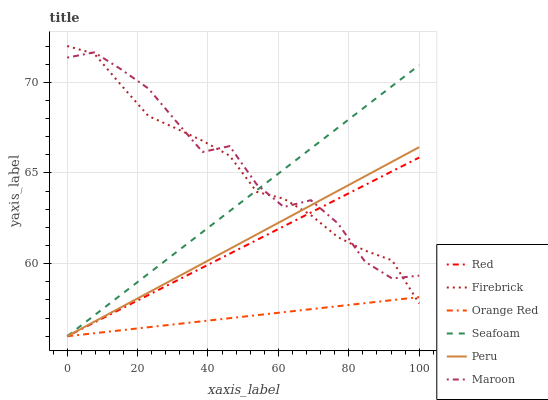Does Orange Red have the minimum area under the curve?
Answer yes or no. Yes. Does Maroon have the maximum area under the curve?
Answer yes or no. Yes. Does Seafoam have the minimum area under the curve?
Answer yes or no. No. Does Seafoam have the maximum area under the curve?
Answer yes or no. No. Is Orange Red the smoothest?
Answer yes or no. Yes. Is Maroon the roughest?
Answer yes or no. Yes. Is Seafoam the smoothest?
Answer yes or no. No. Is Seafoam the roughest?
Answer yes or no. No. Does Seafoam have the lowest value?
Answer yes or no. Yes. Does Maroon have the lowest value?
Answer yes or no. No. Does Firebrick have the highest value?
Answer yes or no. Yes. Does Seafoam have the highest value?
Answer yes or no. No. Is Orange Red less than Maroon?
Answer yes or no. Yes. Is Maroon greater than Orange Red?
Answer yes or no. Yes. Does Orange Red intersect Peru?
Answer yes or no. Yes. Is Orange Red less than Peru?
Answer yes or no. No. Is Orange Red greater than Peru?
Answer yes or no. No. Does Orange Red intersect Maroon?
Answer yes or no. No. 